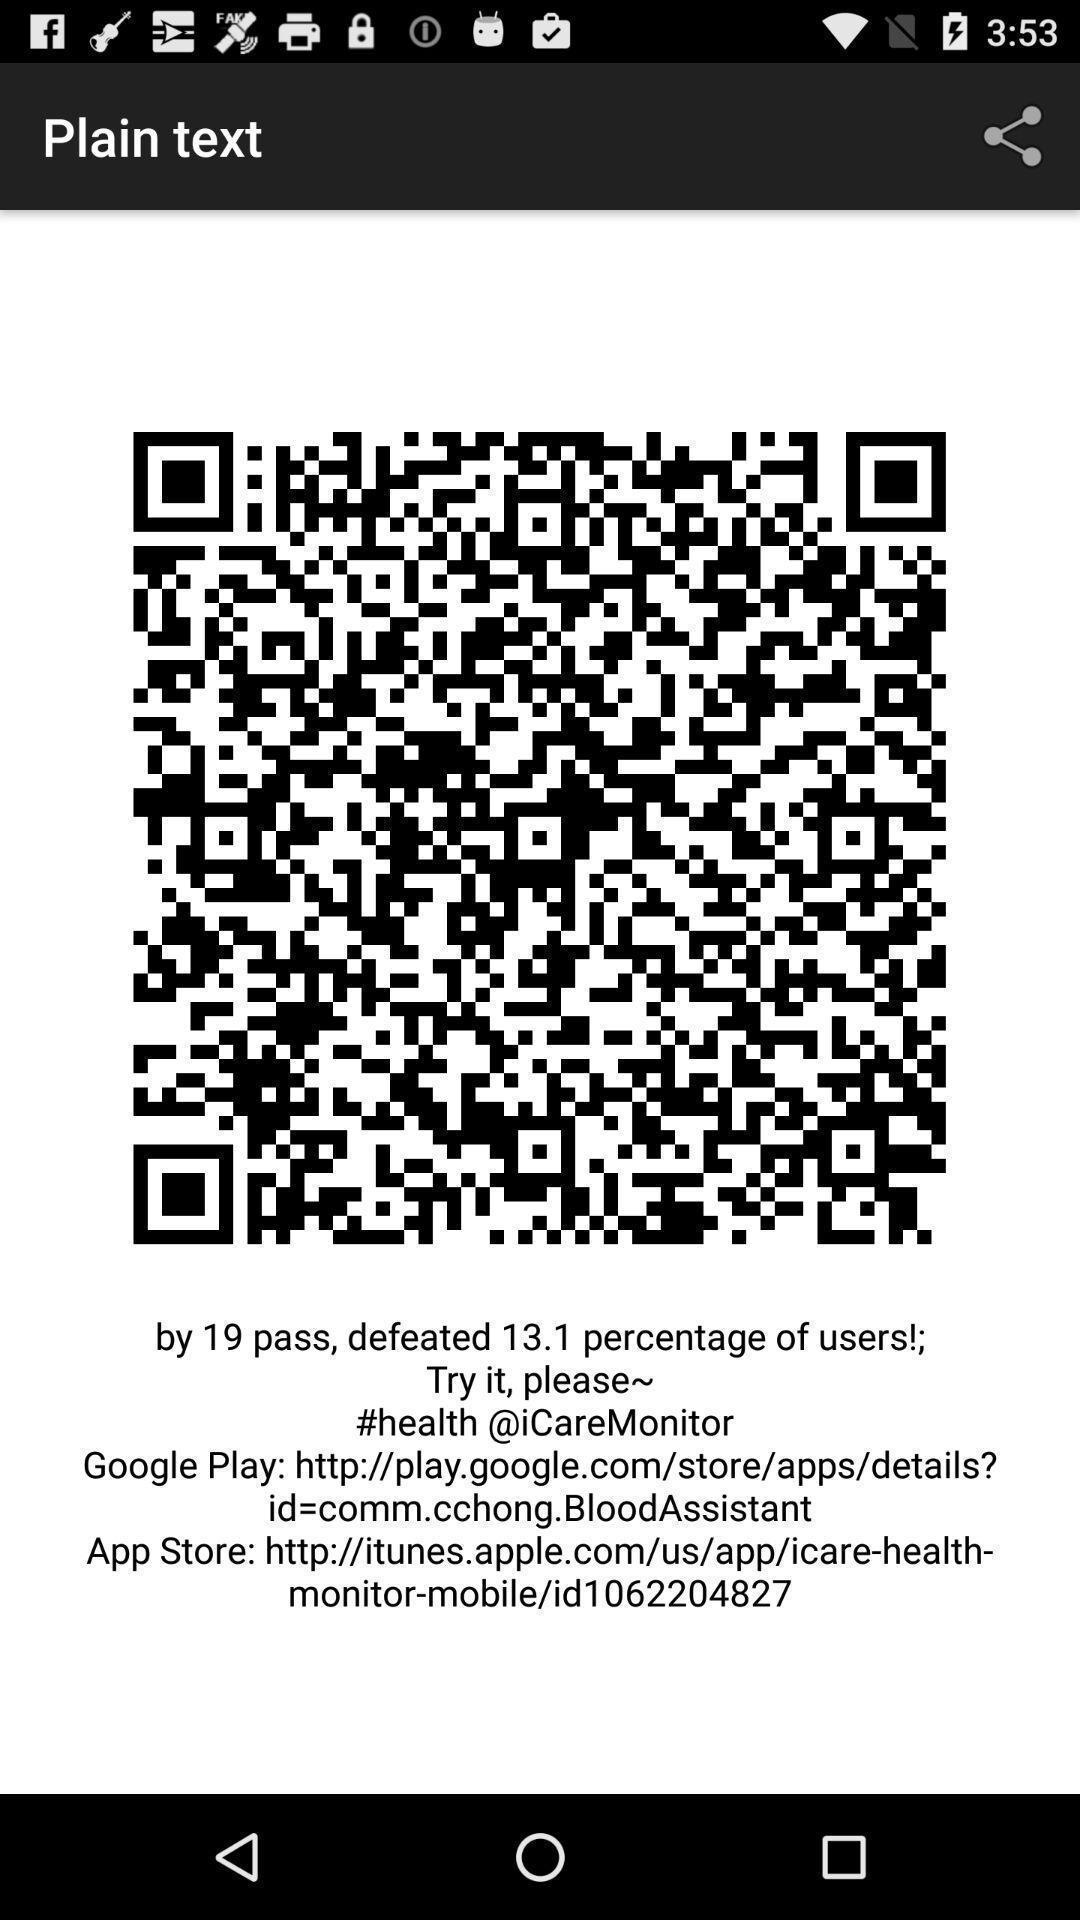What can you discern from this picture? Page displaying qr code and information. 